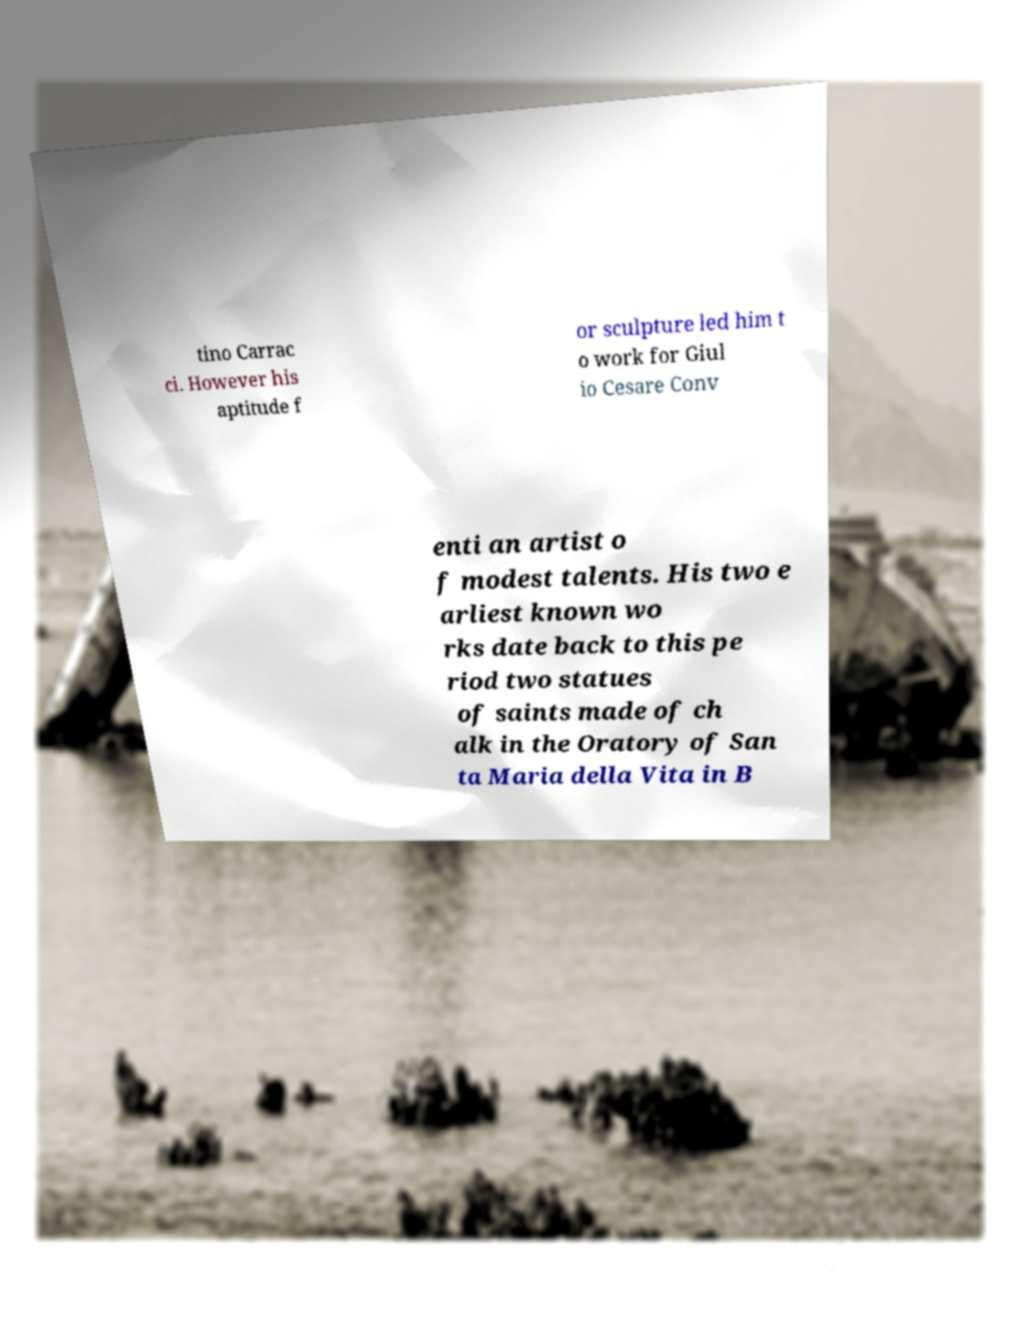Please read and relay the text visible in this image. What does it say? tino Carrac ci. However his aptitude f or sculpture led him t o work for Giul io Cesare Conv enti an artist o f modest talents. His two e arliest known wo rks date back to this pe riod two statues of saints made of ch alk in the Oratory of San ta Maria della Vita in B 